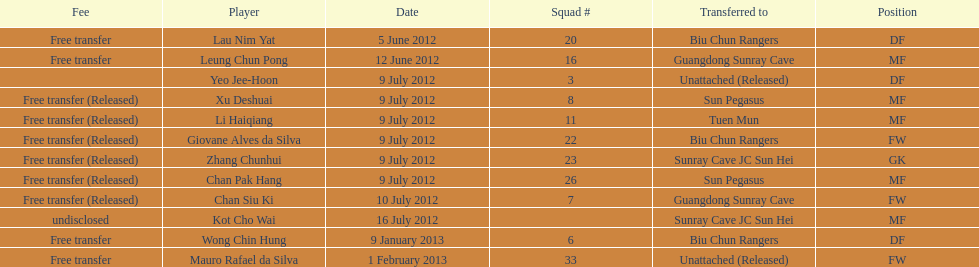Li haiqiang and xu deshuai both played which position? MF. 